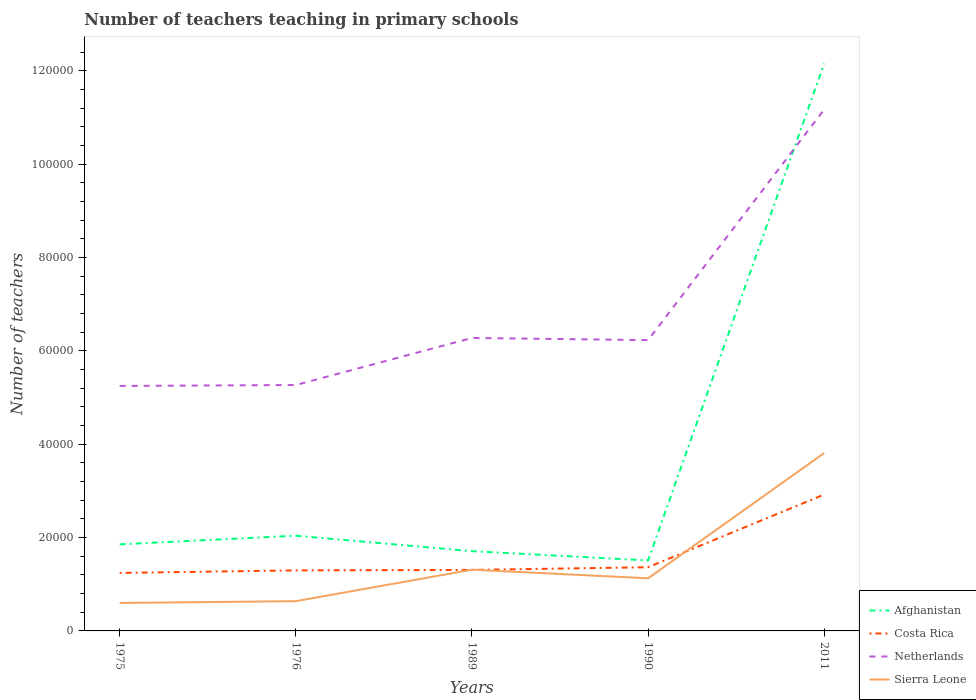Is the number of lines equal to the number of legend labels?
Your response must be concise. Yes. Across all years, what is the maximum number of teachers teaching in primary schools in Afghanistan?
Your answer should be very brief. 1.51e+04. In which year was the number of teachers teaching in primary schools in Costa Rica maximum?
Ensure brevity in your answer.  1975. What is the total number of teachers teaching in primary schools in Sierra Leone in the graph?
Your answer should be compact. -6747. What is the difference between the highest and the second highest number of teachers teaching in primary schools in Netherlands?
Your answer should be very brief. 5.92e+04. What is the difference between the highest and the lowest number of teachers teaching in primary schools in Netherlands?
Ensure brevity in your answer.  1. Is the number of teachers teaching in primary schools in Netherlands strictly greater than the number of teachers teaching in primary schools in Sierra Leone over the years?
Your answer should be compact. No. How many lines are there?
Offer a very short reply. 4. How many years are there in the graph?
Provide a succinct answer. 5. Are the values on the major ticks of Y-axis written in scientific E-notation?
Give a very brief answer. No. Does the graph contain any zero values?
Provide a short and direct response. No. Where does the legend appear in the graph?
Your answer should be very brief. Bottom right. How are the legend labels stacked?
Your response must be concise. Vertical. What is the title of the graph?
Your answer should be very brief. Number of teachers teaching in primary schools. Does "St. Lucia" appear as one of the legend labels in the graph?
Give a very brief answer. No. What is the label or title of the X-axis?
Give a very brief answer. Years. What is the label or title of the Y-axis?
Make the answer very short. Number of teachers. What is the Number of teachers in Afghanistan in 1975?
Your response must be concise. 1.86e+04. What is the Number of teachers of Costa Rica in 1975?
Your response must be concise. 1.24e+04. What is the Number of teachers of Netherlands in 1975?
Provide a short and direct response. 5.25e+04. What is the Number of teachers of Sierra Leone in 1975?
Provide a short and direct response. 5993. What is the Number of teachers of Afghanistan in 1976?
Ensure brevity in your answer.  2.04e+04. What is the Number of teachers of Costa Rica in 1976?
Provide a short and direct response. 1.30e+04. What is the Number of teachers of Netherlands in 1976?
Your answer should be compact. 5.27e+04. What is the Number of teachers of Sierra Leone in 1976?
Your response must be concise. 6373. What is the Number of teachers of Afghanistan in 1989?
Offer a terse response. 1.71e+04. What is the Number of teachers in Costa Rica in 1989?
Ensure brevity in your answer.  1.31e+04. What is the Number of teachers of Netherlands in 1989?
Provide a short and direct response. 6.28e+04. What is the Number of teachers in Sierra Leone in 1989?
Offer a terse response. 1.31e+04. What is the Number of teachers in Afghanistan in 1990?
Ensure brevity in your answer.  1.51e+04. What is the Number of teachers in Costa Rica in 1990?
Offer a terse response. 1.37e+04. What is the Number of teachers in Netherlands in 1990?
Give a very brief answer. 6.23e+04. What is the Number of teachers of Sierra Leone in 1990?
Your answer should be compact. 1.13e+04. What is the Number of teachers in Afghanistan in 2011?
Your answer should be compact. 1.22e+05. What is the Number of teachers of Costa Rica in 2011?
Your response must be concise. 2.92e+04. What is the Number of teachers of Netherlands in 2011?
Your answer should be very brief. 1.12e+05. What is the Number of teachers of Sierra Leone in 2011?
Offer a very short reply. 3.81e+04. Across all years, what is the maximum Number of teachers of Afghanistan?
Give a very brief answer. 1.22e+05. Across all years, what is the maximum Number of teachers of Costa Rica?
Ensure brevity in your answer.  2.92e+04. Across all years, what is the maximum Number of teachers of Netherlands?
Provide a succinct answer. 1.12e+05. Across all years, what is the maximum Number of teachers in Sierra Leone?
Make the answer very short. 3.81e+04. Across all years, what is the minimum Number of teachers in Afghanistan?
Provide a short and direct response. 1.51e+04. Across all years, what is the minimum Number of teachers of Costa Rica?
Your answer should be very brief. 1.24e+04. Across all years, what is the minimum Number of teachers of Netherlands?
Ensure brevity in your answer.  5.25e+04. Across all years, what is the minimum Number of teachers of Sierra Leone?
Ensure brevity in your answer.  5993. What is the total Number of teachers of Afghanistan in the graph?
Your answer should be very brief. 1.93e+05. What is the total Number of teachers of Costa Rica in the graph?
Make the answer very short. 8.14e+04. What is the total Number of teachers of Netherlands in the graph?
Make the answer very short. 3.42e+05. What is the total Number of teachers in Sierra Leone in the graph?
Provide a short and direct response. 7.49e+04. What is the difference between the Number of teachers of Afghanistan in 1975 and that in 1976?
Your answer should be very brief. -1848. What is the difference between the Number of teachers in Costa Rica in 1975 and that in 1976?
Make the answer very short. -544. What is the difference between the Number of teachers of Netherlands in 1975 and that in 1976?
Provide a short and direct response. -197. What is the difference between the Number of teachers in Sierra Leone in 1975 and that in 1976?
Your response must be concise. -380. What is the difference between the Number of teachers in Afghanistan in 1975 and that in 1989?
Offer a terse response. 1469. What is the difference between the Number of teachers in Costa Rica in 1975 and that in 1989?
Your response must be concise. -644. What is the difference between the Number of teachers in Netherlands in 1975 and that in 1989?
Your answer should be compact. -1.03e+04. What is the difference between the Number of teachers in Sierra Leone in 1975 and that in 1989?
Your response must be concise. -7127. What is the difference between the Number of teachers of Afghanistan in 1975 and that in 1990?
Give a very brief answer. 3452. What is the difference between the Number of teachers in Costa Rica in 1975 and that in 1990?
Your answer should be very brief. -1222. What is the difference between the Number of teachers in Netherlands in 1975 and that in 1990?
Give a very brief answer. -9816. What is the difference between the Number of teachers of Sierra Leone in 1975 and that in 1990?
Your answer should be compact. -5287. What is the difference between the Number of teachers of Afghanistan in 1975 and that in 2011?
Your answer should be very brief. -1.03e+05. What is the difference between the Number of teachers of Costa Rica in 1975 and that in 2011?
Your response must be concise. -1.68e+04. What is the difference between the Number of teachers of Netherlands in 1975 and that in 2011?
Ensure brevity in your answer.  -5.92e+04. What is the difference between the Number of teachers of Sierra Leone in 1975 and that in 2011?
Give a very brief answer. -3.21e+04. What is the difference between the Number of teachers of Afghanistan in 1976 and that in 1989?
Offer a terse response. 3317. What is the difference between the Number of teachers in Costa Rica in 1976 and that in 1989?
Your answer should be very brief. -100. What is the difference between the Number of teachers of Netherlands in 1976 and that in 1989?
Ensure brevity in your answer.  -1.01e+04. What is the difference between the Number of teachers of Sierra Leone in 1976 and that in 1989?
Give a very brief answer. -6747. What is the difference between the Number of teachers of Afghanistan in 1976 and that in 1990?
Your answer should be compact. 5300. What is the difference between the Number of teachers in Costa Rica in 1976 and that in 1990?
Offer a terse response. -678. What is the difference between the Number of teachers in Netherlands in 1976 and that in 1990?
Offer a very short reply. -9619. What is the difference between the Number of teachers in Sierra Leone in 1976 and that in 1990?
Provide a succinct answer. -4907. What is the difference between the Number of teachers of Afghanistan in 1976 and that in 2011?
Your answer should be very brief. -1.01e+05. What is the difference between the Number of teachers in Costa Rica in 1976 and that in 2011?
Keep it short and to the point. -1.63e+04. What is the difference between the Number of teachers of Netherlands in 1976 and that in 2011?
Offer a terse response. -5.91e+04. What is the difference between the Number of teachers in Sierra Leone in 1976 and that in 2011?
Give a very brief answer. -3.18e+04. What is the difference between the Number of teachers of Afghanistan in 1989 and that in 1990?
Give a very brief answer. 1983. What is the difference between the Number of teachers in Costa Rica in 1989 and that in 1990?
Your response must be concise. -578. What is the difference between the Number of teachers in Netherlands in 1989 and that in 1990?
Keep it short and to the point. 465. What is the difference between the Number of teachers in Sierra Leone in 1989 and that in 1990?
Give a very brief answer. 1840. What is the difference between the Number of teachers of Afghanistan in 1989 and that in 2011?
Your answer should be compact. -1.05e+05. What is the difference between the Number of teachers of Costa Rica in 1989 and that in 2011?
Offer a terse response. -1.62e+04. What is the difference between the Number of teachers in Netherlands in 1989 and that in 2011?
Offer a very short reply. -4.90e+04. What is the difference between the Number of teachers in Sierra Leone in 1989 and that in 2011?
Your answer should be very brief. -2.50e+04. What is the difference between the Number of teachers in Afghanistan in 1990 and that in 2011?
Offer a very short reply. -1.06e+05. What is the difference between the Number of teachers in Costa Rica in 1990 and that in 2011?
Offer a very short reply. -1.56e+04. What is the difference between the Number of teachers in Netherlands in 1990 and that in 2011?
Offer a terse response. -4.94e+04. What is the difference between the Number of teachers of Sierra Leone in 1990 and that in 2011?
Make the answer very short. -2.68e+04. What is the difference between the Number of teachers of Afghanistan in 1975 and the Number of teachers of Costa Rica in 1976?
Give a very brief answer. 5585. What is the difference between the Number of teachers of Afghanistan in 1975 and the Number of teachers of Netherlands in 1976?
Give a very brief answer. -3.41e+04. What is the difference between the Number of teachers in Afghanistan in 1975 and the Number of teachers in Sierra Leone in 1976?
Your answer should be very brief. 1.22e+04. What is the difference between the Number of teachers in Costa Rica in 1975 and the Number of teachers in Netherlands in 1976?
Your answer should be compact. -4.03e+04. What is the difference between the Number of teachers in Costa Rica in 1975 and the Number of teachers in Sierra Leone in 1976?
Offer a very short reply. 6056. What is the difference between the Number of teachers of Netherlands in 1975 and the Number of teachers of Sierra Leone in 1976?
Offer a terse response. 4.61e+04. What is the difference between the Number of teachers of Afghanistan in 1975 and the Number of teachers of Costa Rica in 1989?
Make the answer very short. 5485. What is the difference between the Number of teachers of Afghanistan in 1975 and the Number of teachers of Netherlands in 1989?
Offer a very short reply. -4.42e+04. What is the difference between the Number of teachers of Afghanistan in 1975 and the Number of teachers of Sierra Leone in 1989?
Make the answer very short. 5438. What is the difference between the Number of teachers in Costa Rica in 1975 and the Number of teachers in Netherlands in 1989?
Provide a succinct answer. -5.04e+04. What is the difference between the Number of teachers of Costa Rica in 1975 and the Number of teachers of Sierra Leone in 1989?
Your answer should be very brief. -691. What is the difference between the Number of teachers in Netherlands in 1975 and the Number of teachers in Sierra Leone in 1989?
Your answer should be very brief. 3.94e+04. What is the difference between the Number of teachers in Afghanistan in 1975 and the Number of teachers in Costa Rica in 1990?
Your answer should be very brief. 4907. What is the difference between the Number of teachers in Afghanistan in 1975 and the Number of teachers in Netherlands in 1990?
Ensure brevity in your answer.  -4.38e+04. What is the difference between the Number of teachers in Afghanistan in 1975 and the Number of teachers in Sierra Leone in 1990?
Provide a succinct answer. 7278. What is the difference between the Number of teachers of Costa Rica in 1975 and the Number of teachers of Netherlands in 1990?
Your answer should be very brief. -4.99e+04. What is the difference between the Number of teachers in Costa Rica in 1975 and the Number of teachers in Sierra Leone in 1990?
Make the answer very short. 1149. What is the difference between the Number of teachers in Netherlands in 1975 and the Number of teachers in Sierra Leone in 1990?
Provide a short and direct response. 4.12e+04. What is the difference between the Number of teachers in Afghanistan in 1975 and the Number of teachers in Costa Rica in 2011?
Your answer should be very brief. -1.07e+04. What is the difference between the Number of teachers of Afghanistan in 1975 and the Number of teachers of Netherlands in 2011?
Your response must be concise. -9.32e+04. What is the difference between the Number of teachers of Afghanistan in 1975 and the Number of teachers of Sierra Leone in 2011?
Provide a succinct answer. -1.96e+04. What is the difference between the Number of teachers of Costa Rica in 1975 and the Number of teachers of Netherlands in 2011?
Provide a short and direct response. -9.93e+04. What is the difference between the Number of teachers of Costa Rica in 1975 and the Number of teachers of Sierra Leone in 2011?
Your response must be concise. -2.57e+04. What is the difference between the Number of teachers in Netherlands in 1975 and the Number of teachers in Sierra Leone in 2011?
Provide a short and direct response. 1.44e+04. What is the difference between the Number of teachers in Afghanistan in 1976 and the Number of teachers in Costa Rica in 1989?
Offer a terse response. 7333. What is the difference between the Number of teachers in Afghanistan in 1976 and the Number of teachers in Netherlands in 1989?
Your answer should be compact. -4.24e+04. What is the difference between the Number of teachers of Afghanistan in 1976 and the Number of teachers of Sierra Leone in 1989?
Keep it short and to the point. 7286. What is the difference between the Number of teachers in Costa Rica in 1976 and the Number of teachers in Netherlands in 1989?
Provide a short and direct response. -4.98e+04. What is the difference between the Number of teachers in Costa Rica in 1976 and the Number of teachers in Sierra Leone in 1989?
Make the answer very short. -147. What is the difference between the Number of teachers of Netherlands in 1976 and the Number of teachers of Sierra Leone in 1989?
Ensure brevity in your answer.  3.96e+04. What is the difference between the Number of teachers of Afghanistan in 1976 and the Number of teachers of Costa Rica in 1990?
Your response must be concise. 6755. What is the difference between the Number of teachers in Afghanistan in 1976 and the Number of teachers in Netherlands in 1990?
Your response must be concise. -4.19e+04. What is the difference between the Number of teachers in Afghanistan in 1976 and the Number of teachers in Sierra Leone in 1990?
Make the answer very short. 9126. What is the difference between the Number of teachers in Costa Rica in 1976 and the Number of teachers in Netherlands in 1990?
Ensure brevity in your answer.  -4.93e+04. What is the difference between the Number of teachers of Costa Rica in 1976 and the Number of teachers of Sierra Leone in 1990?
Keep it short and to the point. 1693. What is the difference between the Number of teachers of Netherlands in 1976 and the Number of teachers of Sierra Leone in 1990?
Give a very brief answer. 4.14e+04. What is the difference between the Number of teachers of Afghanistan in 1976 and the Number of teachers of Costa Rica in 2011?
Ensure brevity in your answer.  -8827. What is the difference between the Number of teachers of Afghanistan in 1976 and the Number of teachers of Netherlands in 2011?
Offer a terse response. -9.13e+04. What is the difference between the Number of teachers in Afghanistan in 1976 and the Number of teachers in Sierra Leone in 2011?
Ensure brevity in your answer.  -1.77e+04. What is the difference between the Number of teachers in Costa Rica in 1976 and the Number of teachers in Netherlands in 2011?
Provide a succinct answer. -9.88e+04. What is the difference between the Number of teachers in Costa Rica in 1976 and the Number of teachers in Sierra Leone in 2011?
Give a very brief answer. -2.52e+04. What is the difference between the Number of teachers of Netherlands in 1976 and the Number of teachers of Sierra Leone in 2011?
Offer a terse response. 1.46e+04. What is the difference between the Number of teachers in Afghanistan in 1989 and the Number of teachers in Costa Rica in 1990?
Ensure brevity in your answer.  3438. What is the difference between the Number of teachers in Afghanistan in 1989 and the Number of teachers in Netherlands in 1990?
Provide a succinct answer. -4.52e+04. What is the difference between the Number of teachers of Afghanistan in 1989 and the Number of teachers of Sierra Leone in 1990?
Provide a succinct answer. 5809. What is the difference between the Number of teachers of Costa Rica in 1989 and the Number of teachers of Netherlands in 1990?
Ensure brevity in your answer.  -4.92e+04. What is the difference between the Number of teachers in Costa Rica in 1989 and the Number of teachers in Sierra Leone in 1990?
Offer a very short reply. 1793. What is the difference between the Number of teachers of Netherlands in 1989 and the Number of teachers of Sierra Leone in 1990?
Your response must be concise. 5.15e+04. What is the difference between the Number of teachers of Afghanistan in 1989 and the Number of teachers of Costa Rica in 2011?
Provide a short and direct response. -1.21e+04. What is the difference between the Number of teachers of Afghanistan in 1989 and the Number of teachers of Netherlands in 2011?
Give a very brief answer. -9.47e+04. What is the difference between the Number of teachers in Afghanistan in 1989 and the Number of teachers in Sierra Leone in 2011?
Your response must be concise. -2.10e+04. What is the difference between the Number of teachers in Costa Rica in 1989 and the Number of teachers in Netherlands in 2011?
Give a very brief answer. -9.87e+04. What is the difference between the Number of teachers of Costa Rica in 1989 and the Number of teachers of Sierra Leone in 2011?
Your answer should be compact. -2.51e+04. What is the difference between the Number of teachers of Netherlands in 1989 and the Number of teachers of Sierra Leone in 2011?
Offer a terse response. 2.47e+04. What is the difference between the Number of teachers in Afghanistan in 1990 and the Number of teachers in Costa Rica in 2011?
Your answer should be compact. -1.41e+04. What is the difference between the Number of teachers in Afghanistan in 1990 and the Number of teachers in Netherlands in 2011?
Give a very brief answer. -9.66e+04. What is the difference between the Number of teachers in Afghanistan in 1990 and the Number of teachers in Sierra Leone in 2011?
Your response must be concise. -2.30e+04. What is the difference between the Number of teachers in Costa Rica in 1990 and the Number of teachers in Netherlands in 2011?
Provide a short and direct response. -9.81e+04. What is the difference between the Number of teachers of Costa Rica in 1990 and the Number of teachers of Sierra Leone in 2011?
Offer a very short reply. -2.45e+04. What is the difference between the Number of teachers of Netherlands in 1990 and the Number of teachers of Sierra Leone in 2011?
Offer a very short reply. 2.42e+04. What is the average Number of teachers in Afghanistan per year?
Offer a terse response. 3.86e+04. What is the average Number of teachers of Costa Rica per year?
Offer a very short reply. 1.63e+04. What is the average Number of teachers of Netherlands per year?
Your answer should be very brief. 6.84e+04. What is the average Number of teachers in Sierra Leone per year?
Provide a succinct answer. 1.50e+04. In the year 1975, what is the difference between the Number of teachers of Afghanistan and Number of teachers of Costa Rica?
Your response must be concise. 6129. In the year 1975, what is the difference between the Number of teachers in Afghanistan and Number of teachers in Netherlands?
Keep it short and to the point. -3.39e+04. In the year 1975, what is the difference between the Number of teachers of Afghanistan and Number of teachers of Sierra Leone?
Ensure brevity in your answer.  1.26e+04. In the year 1975, what is the difference between the Number of teachers of Costa Rica and Number of teachers of Netherlands?
Make the answer very short. -4.01e+04. In the year 1975, what is the difference between the Number of teachers of Costa Rica and Number of teachers of Sierra Leone?
Provide a succinct answer. 6436. In the year 1975, what is the difference between the Number of teachers of Netherlands and Number of teachers of Sierra Leone?
Your response must be concise. 4.65e+04. In the year 1976, what is the difference between the Number of teachers of Afghanistan and Number of teachers of Costa Rica?
Ensure brevity in your answer.  7433. In the year 1976, what is the difference between the Number of teachers of Afghanistan and Number of teachers of Netherlands?
Offer a terse response. -3.23e+04. In the year 1976, what is the difference between the Number of teachers of Afghanistan and Number of teachers of Sierra Leone?
Your answer should be compact. 1.40e+04. In the year 1976, what is the difference between the Number of teachers in Costa Rica and Number of teachers in Netherlands?
Your response must be concise. -3.97e+04. In the year 1976, what is the difference between the Number of teachers of Costa Rica and Number of teachers of Sierra Leone?
Keep it short and to the point. 6600. In the year 1976, what is the difference between the Number of teachers of Netherlands and Number of teachers of Sierra Leone?
Your answer should be very brief. 4.63e+04. In the year 1989, what is the difference between the Number of teachers in Afghanistan and Number of teachers in Costa Rica?
Provide a succinct answer. 4016. In the year 1989, what is the difference between the Number of teachers of Afghanistan and Number of teachers of Netherlands?
Provide a succinct answer. -4.57e+04. In the year 1989, what is the difference between the Number of teachers of Afghanistan and Number of teachers of Sierra Leone?
Your answer should be compact. 3969. In the year 1989, what is the difference between the Number of teachers of Costa Rica and Number of teachers of Netherlands?
Ensure brevity in your answer.  -4.97e+04. In the year 1989, what is the difference between the Number of teachers in Costa Rica and Number of teachers in Sierra Leone?
Offer a terse response. -47. In the year 1989, what is the difference between the Number of teachers of Netherlands and Number of teachers of Sierra Leone?
Provide a succinct answer. 4.97e+04. In the year 1990, what is the difference between the Number of teachers in Afghanistan and Number of teachers in Costa Rica?
Offer a terse response. 1455. In the year 1990, what is the difference between the Number of teachers in Afghanistan and Number of teachers in Netherlands?
Your answer should be very brief. -4.72e+04. In the year 1990, what is the difference between the Number of teachers of Afghanistan and Number of teachers of Sierra Leone?
Keep it short and to the point. 3826. In the year 1990, what is the difference between the Number of teachers of Costa Rica and Number of teachers of Netherlands?
Give a very brief answer. -4.87e+04. In the year 1990, what is the difference between the Number of teachers in Costa Rica and Number of teachers in Sierra Leone?
Keep it short and to the point. 2371. In the year 1990, what is the difference between the Number of teachers in Netherlands and Number of teachers in Sierra Leone?
Offer a terse response. 5.10e+04. In the year 2011, what is the difference between the Number of teachers in Afghanistan and Number of teachers in Costa Rica?
Keep it short and to the point. 9.24e+04. In the year 2011, what is the difference between the Number of teachers of Afghanistan and Number of teachers of Netherlands?
Give a very brief answer. 9841. In the year 2011, what is the difference between the Number of teachers of Afghanistan and Number of teachers of Sierra Leone?
Offer a very short reply. 8.35e+04. In the year 2011, what is the difference between the Number of teachers of Costa Rica and Number of teachers of Netherlands?
Provide a short and direct response. -8.25e+04. In the year 2011, what is the difference between the Number of teachers in Costa Rica and Number of teachers in Sierra Leone?
Offer a terse response. -8892. In the year 2011, what is the difference between the Number of teachers in Netherlands and Number of teachers in Sierra Leone?
Make the answer very short. 7.36e+04. What is the ratio of the Number of teachers in Afghanistan in 1975 to that in 1976?
Ensure brevity in your answer.  0.91. What is the ratio of the Number of teachers of Costa Rica in 1975 to that in 1976?
Make the answer very short. 0.96. What is the ratio of the Number of teachers of Netherlands in 1975 to that in 1976?
Provide a short and direct response. 1. What is the ratio of the Number of teachers of Sierra Leone in 1975 to that in 1976?
Offer a terse response. 0.94. What is the ratio of the Number of teachers of Afghanistan in 1975 to that in 1989?
Provide a short and direct response. 1.09. What is the ratio of the Number of teachers in Costa Rica in 1975 to that in 1989?
Offer a terse response. 0.95. What is the ratio of the Number of teachers of Netherlands in 1975 to that in 1989?
Your answer should be compact. 0.84. What is the ratio of the Number of teachers in Sierra Leone in 1975 to that in 1989?
Give a very brief answer. 0.46. What is the ratio of the Number of teachers in Afghanistan in 1975 to that in 1990?
Offer a terse response. 1.23. What is the ratio of the Number of teachers of Costa Rica in 1975 to that in 1990?
Give a very brief answer. 0.91. What is the ratio of the Number of teachers of Netherlands in 1975 to that in 1990?
Provide a short and direct response. 0.84. What is the ratio of the Number of teachers in Sierra Leone in 1975 to that in 1990?
Your answer should be compact. 0.53. What is the ratio of the Number of teachers of Afghanistan in 1975 to that in 2011?
Make the answer very short. 0.15. What is the ratio of the Number of teachers of Costa Rica in 1975 to that in 2011?
Ensure brevity in your answer.  0.43. What is the ratio of the Number of teachers of Netherlands in 1975 to that in 2011?
Your response must be concise. 0.47. What is the ratio of the Number of teachers in Sierra Leone in 1975 to that in 2011?
Offer a very short reply. 0.16. What is the ratio of the Number of teachers in Afghanistan in 1976 to that in 1989?
Offer a very short reply. 1.19. What is the ratio of the Number of teachers of Netherlands in 1976 to that in 1989?
Offer a terse response. 0.84. What is the ratio of the Number of teachers in Sierra Leone in 1976 to that in 1989?
Your answer should be compact. 0.49. What is the ratio of the Number of teachers in Afghanistan in 1976 to that in 1990?
Ensure brevity in your answer.  1.35. What is the ratio of the Number of teachers in Costa Rica in 1976 to that in 1990?
Keep it short and to the point. 0.95. What is the ratio of the Number of teachers of Netherlands in 1976 to that in 1990?
Your answer should be very brief. 0.85. What is the ratio of the Number of teachers of Sierra Leone in 1976 to that in 1990?
Make the answer very short. 0.56. What is the ratio of the Number of teachers of Afghanistan in 1976 to that in 2011?
Keep it short and to the point. 0.17. What is the ratio of the Number of teachers in Costa Rica in 1976 to that in 2011?
Provide a succinct answer. 0.44. What is the ratio of the Number of teachers in Netherlands in 1976 to that in 2011?
Ensure brevity in your answer.  0.47. What is the ratio of the Number of teachers in Sierra Leone in 1976 to that in 2011?
Your answer should be compact. 0.17. What is the ratio of the Number of teachers of Afghanistan in 1989 to that in 1990?
Provide a succinct answer. 1.13. What is the ratio of the Number of teachers in Costa Rica in 1989 to that in 1990?
Offer a very short reply. 0.96. What is the ratio of the Number of teachers in Netherlands in 1989 to that in 1990?
Your response must be concise. 1.01. What is the ratio of the Number of teachers in Sierra Leone in 1989 to that in 1990?
Keep it short and to the point. 1.16. What is the ratio of the Number of teachers of Afghanistan in 1989 to that in 2011?
Make the answer very short. 0.14. What is the ratio of the Number of teachers of Costa Rica in 1989 to that in 2011?
Your response must be concise. 0.45. What is the ratio of the Number of teachers of Netherlands in 1989 to that in 2011?
Keep it short and to the point. 0.56. What is the ratio of the Number of teachers of Sierra Leone in 1989 to that in 2011?
Keep it short and to the point. 0.34. What is the ratio of the Number of teachers of Afghanistan in 1990 to that in 2011?
Offer a very short reply. 0.12. What is the ratio of the Number of teachers of Costa Rica in 1990 to that in 2011?
Ensure brevity in your answer.  0.47. What is the ratio of the Number of teachers of Netherlands in 1990 to that in 2011?
Provide a succinct answer. 0.56. What is the ratio of the Number of teachers in Sierra Leone in 1990 to that in 2011?
Offer a very short reply. 0.3. What is the difference between the highest and the second highest Number of teachers of Afghanistan?
Your answer should be compact. 1.01e+05. What is the difference between the highest and the second highest Number of teachers in Costa Rica?
Provide a succinct answer. 1.56e+04. What is the difference between the highest and the second highest Number of teachers of Netherlands?
Your response must be concise. 4.90e+04. What is the difference between the highest and the second highest Number of teachers in Sierra Leone?
Provide a short and direct response. 2.50e+04. What is the difference between the highest and the lowest Number of teachers in Afghanistan?
Ensure brevity in your answer.  1.06e+05. What is the difference between the highest and the lowest Number of teachers of Costa Rica?
Provide a short and direct response. 1.68e+04. What is the difference between the highest and the lowest Number of teachers in Netherlands?
Make the answer very short. 5.92e+04. What is the difference between the highest and the lowest Number of teachers in Sierra Leone?
Make the answer very short. 3.21e+04. 